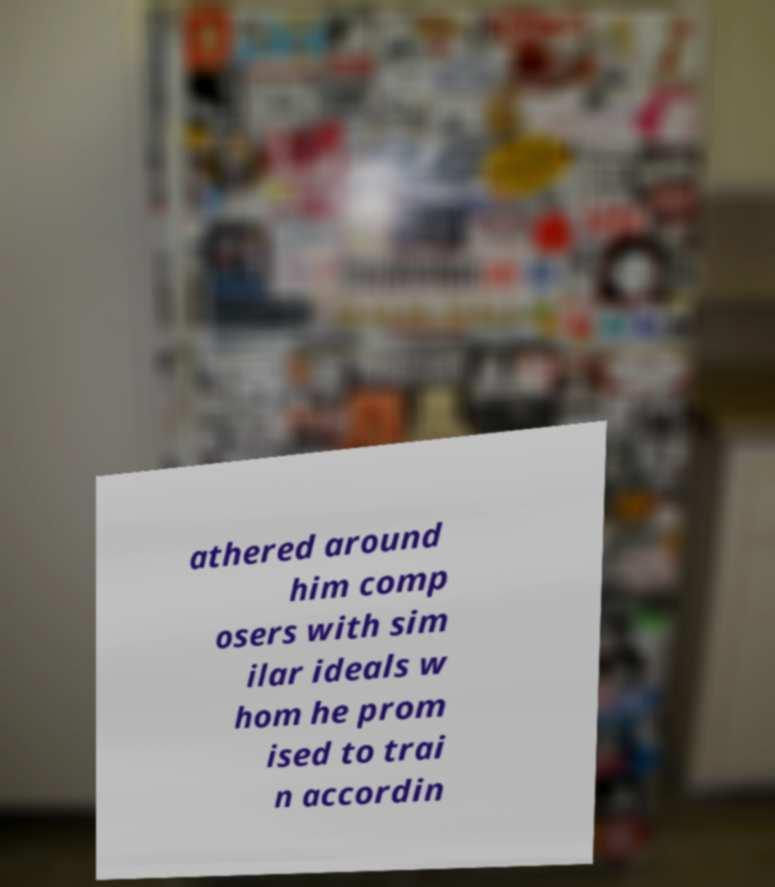I need the written content from this picture converted into text. Can you do that? athered around him comp osers with sim ilar ideals w hom he prom ised to trai n accordin 